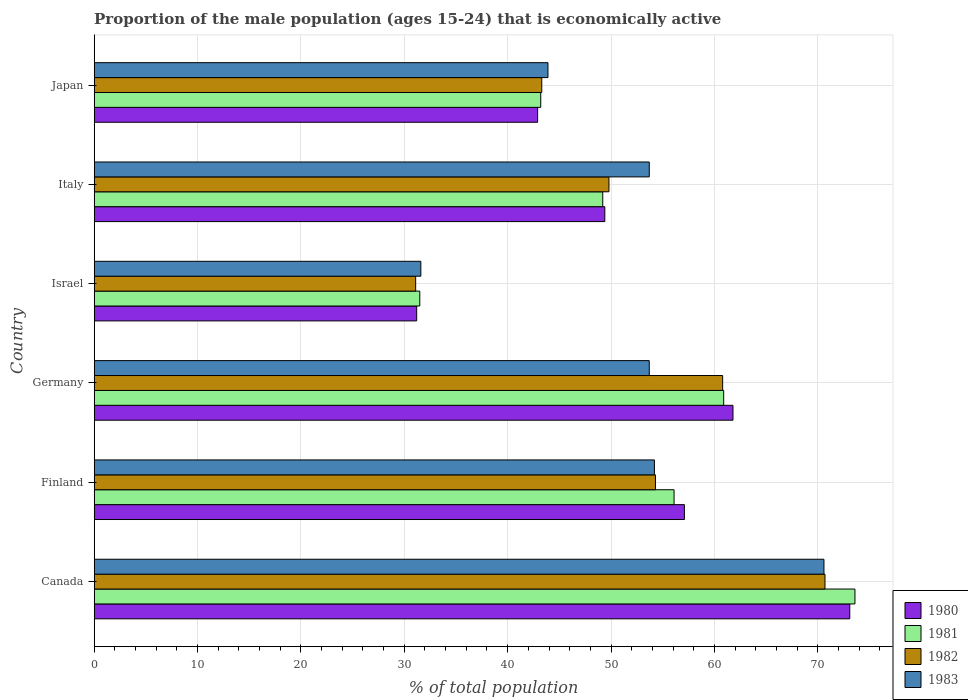How many different coloured bars are there?
Provide a succinct answer. 4. Are the number of bars per tick equal to the number of legend labels?
Provide a succinct answer. Yes. How many bars are there on the 6th tick from the top?
Your answer should be very brief. 4. In how many cases, is the number of bars for a given country not equal to the number of legend labels?
Provide a succinct answer. 0. What is the proportion of the male population that is economically active in 1980 in Finland?
Your answer should be compact. 57.1. Across all countries, what is the maximum proportion of the male population that is economically active in 1983?
Ensure brevity in your answer.  70.6. Across all countries, what is the minimum proportion of the male population that is economically active in 1983?
Ensure brevity in your answer.  31.6. What is the total proportion of the male population that is economically active in 1981 in the graph?
Your answer should be compact. 314.5. What is the difference between the proportion of the male population that is economically active in 1981 in Israel and the proportion of the male population that is economically active in 1983 in Germany?
Ensure brevity in your answer.  -22.2. What is the average proportion of the male population that is economically active in 1983 per country?
Give a very brief answer. 51.28. What is the difference between the proportion of the male population that is economically active in 1982 and proportion of the male population that is economically active in 1981 in Canada?
Your response must be concise. -2.9. In how many countries, is the proportion of the male population that is economically active in 1982 greater than 8 %?
Your answer should be very brief. 6. What is the ratio of the proportion of the male population that is economically active in 1980 in Italy to that in Japan?
Provide a succinct answer. 1.15. What is the difference between the highest and the second highest proportion of the male population that is economically active in 1980?
Offer a very short reply. 11.3. What is the difference between the highest and the lowest proportion of the male population that is economically active in 1983?
Give a very brief answer. 39. Is it the case that in every country, the sum of the proportion of the male population that is economically active in 1980 and proportion of the male population that is economically active in 1981 is greater than the sum of proportion of the male population that is economically active in 1983 and proportion of the male population that is economically active in 1982?
Your answer should be compact. No. What does the 4th bar from the top in Japan represents?
Keep it short and to the point. 1980. Is it the case that in every country, the sum of the proportion of the male population that is economically active in 1983 and proportion of the male population that is economically active in 1981 is greater than the proportion of the male population that is economically active in 1980?
Offer a very short reply. Yes. How many bars are there?
Ensure brevity in your answer.  24. What is the difference between two consecutive major ticks on the X-axis?
Offer a very short reply. 10. Are the values on the major ticks of X-axis written in scientific E-notation?
Your answer should be very brief. No. Does the graph contain grids?
Your response must be concise. Yes. How are the legend labels stacked?
Keep it short and to the point. Vertical. What is the title of the graph?
Your answer should be very brief. Proportion of the male population (ages 15-24) that is economically active. Does "1992" appear as one of the legend labels in the graph?
Keep it short and to the point. No. What is the label or title of the X-axis?
Offer a terse response. % of total population. What is the label or title of the Y-axis?
Provide a short and direct response. Country. What is the % of total population of 1980 in Canada?
Keep it short and to the point. 73.1. What is the % of total population of 1981 in Canada?
Keep it short and to the point. 73.6. What is the % of total population of 1982 in Canada?
Offer a very short reply. 70.7. What is the % of total population of 1983 in Canada?
Provide a short and direct response. 70.6. What is the % of total population of 1980 in Finland?
Provide a short and direct response. 57.1. What is the % of total population of 1981 in Finland?
Give a very brief answer. 56.1. What is the % of total population of 1982 in Finland?
Give a very brief answer. 54.3. What is the % of total population of 1983 in Finland?
Give a very brief answer. 54.2. What is the % of total population in 1980 in Germany?
Your answer should be compact. 61.8. What is the % of total population of 1981 in Germany?
Offer a terse response. 60.9. What is the % of total population in 1982 in Germany?
Your answer should be compact. 60.8. What is the % of total population of 1983 in Germany?
Keep it short and to the point. 53.7. What is the % of total population of 1980 in Israel?
Give a very brief answer. 31.2. What is the % of total population in 1981 in Israel?
Make the answer very short. 31.5. What is the % of total population in 1982 in Israel?
Provide a succinct answer. 31.1. What is the % of total population of 1983 in Israel?
Ensure brevity in your answer.  31.6. What is the % of total population of 1980 in Italy?
Your response must be concise. 49.4. What is the % of total population in 1981 in Italy?
Your answer should be compact. 49.2. What is the % of total population in 1982 in Italy?
Provide a short and direct response. 49.8. What is the % of total population in 1983 in Italy?
Your answer should be compact. 53.7. What is the % of total population in 1980 in Japan?
Provide a succinct answer. 42.9. What is the % of total population in 1981 in Japan?
Offer a terse response. 43.2. What is the % of total population of 1982 in Japan?
Provide a short and direct response. 43.3. What is the % of total population of 1983 in Japan?
Make the answer very short. 43.9. Across all countries, what is the maximum % of total population in 1980?
Your answer should be very brief. 73.1. Across all countries, what is the maximum % of total population in 1981?
Your answer should be very brief. 73.6. Across all countries, what is the maximum % of total population of 1982?
Provide a succinct answer. 70.7. Across all countries, what is the maximum % of total population in 1983?
Provide a succinct answer. 70.6. Across all countries, what is the minimum % of total population in 1980?
Give a very brief answer. 31.2. Across all countries, what is the minimum % of total population of 1981?
Keep it short and to the point. 31.5. Across all countries, what is the minimum % of total population of 1982?
Ensure brevity in your answer.  31.1. Across all countries, what is the minimum % of total population in 1983?
Keep it short and to the point. 31.6. What is the total % of total population of 1980 in the graph?
Make the answer very short. 315.5. What is the total % of total population of 1981 in the graph?
Give a very brief answer. 314.5. What is the total % of total population of 1982 in the graph?
Give a very brief answer. 310. What is the total % of total population in 1983 in the graph?
Provide a succinct answer. 307.7. What is the difference between the % of total population of 1980 in Canada and that in Finland?
Offer a terse response. 16. What is the difference between the % of total population in 1981 in Canada and that in Finland?
Offer a terse response. 17.5. What is the difference between the % of total population in 1982 in Canada and that in Finland?
Make the answer very short. 16.4. What is the difference between the % of total population of 1981 in Canada and that in Germany?
Make the answer very short. 12.7. What is the difference between the % of total population of 1983 in Canada and that in Germany?
Offer a terse response. 16.9. What is the difference between the % of total population in 1980 in Canada and that in Israel?
Your answer should be compact. 41.9. What is the difference between the % of total population in 1981 in Canada and that in Israel?
Your answer should be very brief. 42.1. What is the difference between the % of total population in 1982 in Canada and that in Israel?
Ensure brevity in your answer.  39.6. What is the difference between the % of total population in 1980 in Canada and that in Italy?
Offer a terse response. 23.7. What is the difference between the % of total population in 1981 in Canada and that in Italy?
Give a very brief answer. 24.4. What is the difference between the % of total population in 1982 in Canada and that in Italy?
Give a very brief answer. 20.9. What is the difference between the % of total population in 1983 in Canada and that in Italy?
Offer a very short reply. 16.9. What is the difference between the % of total population of 1980 in Canada and that in Japan?
Offer a very short reply. 30.2. What is the difference between the % of total population of 1981 in Canada and that in Japan?
Offer a very short reply. 30.4. What is the difference between the % of total population in 1982 in Canada and that in Japan?
Your answer should be very brief. 27.4. What is the difference between the % of total population in 1983 in Canada and that in Japan?
Provide a succinct answer. 26.7. What is the difference between the % of total population of 1981 in Finland and that in Germany?
Provide a succinct answer. -4.8. What is the difference between the % of total population of 1980 in Finland and that in Israel?
Offer a very short reply. 25.9. What is the difference between the % of total population in 1981 in Finland and that in Israel?
Provide a short and direct response. 24.6. What is the difference between the % of total population of 1982 in Finland and that in Israel?
Make the answer very short. 23.2. What is the difference between the % of total population in 1983 in Finland and that in Israel?
Make the answer very short. 22.6. What is the difference between the % of total population of 1981 in Finland and that in Italy?
Offer a very short reply. 6.9. What is the difference between the % of total population of 1982 in Finland and that in Italy?
Your answer should be very brief. 4.5. What is the difference between the % of total population of 1983 in Finland and that in Italy?
Keep it short and to the point. 0.5. What is the difference between the % of total population in 1981 in Finland and that in Japan?
Your response must be concise. 12.9. What is the difference between the % of total population in 1982 in Finland and that in Japan?
Your response must be concise. 11. What is the difference between the % of total population of 1983 in Finland and that in Japan?
Make the answer very short. 10.3. What is the difference between the % of total population of 1980 in Germany and that in Israel?
Give a very brief answer. 30.6. What is the difference between the % of total population in 1981 in Germany and that in Israel?
Your answer should be very brief. 29.4. What is the difference between the % of total population in 1982 in Germany and that in Israel?
Provide a succinct answer. 29.7. What is the difference between the % of total population in 1983 in Germany and that in Israel?
Make the answer very short. 22.1. What is the difference between the % of total population in 1980 in Germany and that in Italy?
Your answer should be very brief. 12.4. What is the difference between the % of total population of 1981 in Germany and that in Italy?
Your answer should be very brief. 11.7. What is the difference between the % of total population in 1982 in Germany and that in Italy?
Your answer should be compact. 11. What is the difference between the % of total population of 1983 in Germany and that in Italy?
Offer a very short reply. 0. What is the difference between the % of total population of 1980 in Germany and that in Japan?
Your answer should be compact. 18.9. What is the difference between the % of total population of 1982 in Germany and that in Japan?
Offer a terse response. 17.5. What is the difference between the % of total population in 1980 in Israel and that in Italy?
Your response must be concise. -18.2. What is the difference between the % of total population in 1981 in Israel and that in Italy?
Ensure brevity in your answer.  -17.7. What is the difference between the % of total population of 1982 in Israel and that in Italy?
Ensure brevity in your answer.  -18.7. What is the difference between the % of total population of 1983 in Israel and that in Italy?
Keep it short and to the point. -22.1. What is the difference between the % of total population in 1980 in Canada and the % of total population in 1981 in Finland?
Provide a short and direct response. 17. What is the difference between the % of total population in 1981 in Canada and the % of total population in 1982 in Finland?
Make the answer very short. 19.3. What is the difference between the % of total population of 1981 in Canada and the % of total population of 1983 in Finland?
Provide a succinct answer. 19.4. What is the difference between the % of total population in 1982 in Canada and the % of total population in 1983 in Finland?
Offer a very short reply. 16.5. What is the difference between the % of total population in 1980 in Canada and the % of total population in 1982 in Germany?
Keep it short and to the point. 12.3. What is the difference between the % of total population in 1981 in Canada and the % of total population in 1983 in Germany?
Offer a terse response. 19.9. What is the difference between the % of total population in 1980 in Canada and the % of total population in 1981 in Israel?
Give a very brief answer. 41.6. What is the difference between the % of total population of 1980 in Canada and the % of total population of 1983 in Israel?
Ensure brevity in your answer.  41.5. What is the difference between the % of total population of 1981 in Canada and the % of total population of 1982 in Israel?
Ensure brevity in your answer.  42.5. What is the difference between the % of total population of 1982 in Canada and the % of total population of 1983 in Israel?
Your response must be concise. 39.1. What is the difference between the % of total population in 1980 in Canada and the % of total population in 1981 in Italy?
Provide a short and direct response. 23.9. What is the difference between the % of total population in 1980 in Canada and the % of total population in 1982 in Italy?
Ensure brevity in your answer.  23.3. What is the difference between the % of total population of 1981 in Canada and the % of total population of 1982 in Italy?
Your answer should be compact. 23.8. What is the difference between the % of total population of 1980 in Canada and the % of total population of 1981 in Japan?
Your answer should be compact. 29.9. What is the difference between the % of total population in 1980 in Canada and the % of total population in 1982 in Japan?
Your response must be concise. 29.8. What is the difference between the % of total population of 1980 in Canada and the % of total population of 1983 in Japan?
Offer a terse response. 29.2. What is the difference between the % of total population in 1981 in Canada and the % of total population in 1982 in Japan?
Your answer should be compact. 30.3. What is the difference between the % of total population of 1981 in Canada and the % of total population of 1983 in Japan?
Provide a short and direct response. 29.7. What is the difference between the % of total population of 1982 in Canada and the % of total population of 1983 in Japan?
Make the answer very short. 26.8. What is the difference between the % of total population of 1980 in Finland and the % of total population of 1981 in Germany?
Ensure brevity in your answer.  -3.8. What is the difference between the % of total population in 1980 in Finland and the % of total population in 1983 in Germany?
Keep it short and to the point. 3.4. What is the difference between the % of total population in 1980 in Finland and the % of total population in 1981 in Israel?
Keep it short and to the point. 25.6. What is the difference between the % of total population of 1980 in Finland and the % of total population of 1983 in Israel?
Your answer should be very brief. 25.5. What is the difference between the % of total population of 1982 in Finland and the % of total population of 1983 in Israel?
Provide a succinct answer. 22.7. What is the difference between the % of total population in 1980 in Finland and the % of total population in 1981 in Italy?
Provide a short and direct response. 7.9. What is the difference between the % of total population in 1980 in Finland and the % of total population in 1982 in Italy?
Offer a very short reply. 7.3. What is the difference between the % of total population in 1981 in Finland and the % of total population in 1982 in Italy?
Ensure brevity in your answer.  6.3. What is the difference between the % of total population in 1980 in Finland and the % of total population in 1981 in Japan?
Make the answer very short. 13.9. What is the difference between the % of total population of 1980 in Finland and the % of total population of 1982 in Japan?
Your answer should be compact. 13.8. What is the difference between the % of total population in 1981 in Finland and the % of total population in 1982 in Japan?
Offer a very short reply. 12.8. What is the difference between the % of total population in 1981 in Finland and the % of total population in 1983 in Japan?
Your answer should be compact. 12.2. What is the difference between the % of total population in 1982 in Finland and the % of total population in 1983 in Japan?
Offer a terse response. 10.4. What is the difference between the % of total population of 1980 in Germany and the % of total population of 1981 in Israel?
Your answer should be compact. 30.3. What is the difference between the % of total population of 1980 in Germany and the % of total population of 1982 in Israel?
Offer a terse response. 30.7. What is the difference between the % of total population of 1980 in Germany and the % of total population of 1983 in Israel?
Your answer should be very brief. 30.2. What is the difference between the % of total population of 1981 in Germany and the % of total population of 1982 in Israel?
Provide a succinct answer. 29.8. What is the difference between the % of total population of 1981 in Germany and the % of total population of 1983 in Israel?
Provide a succinct answer. 29.3. What is the difference between the % of total population in 1982 in Germany and the % of total population in 1983 in Israel?
Provide a short and direct response. 29.2. What is the difference between the % of total population of 1980 in Germany and the % of total population of 1982 in Italy?
Your response must be concise. 12. What is the difference between the % of total population in 1980 in Germany and the % of total population in 1983 in Italy?
Your response must be concise. 8.1. What is the difference between the % of total population in 1981 in Germany and the % of total population in 1982 in Italy?
Keep it short and to the point. 11.1. What is the difference between the % of total population of 1981 in Germany and the % of total population of 1983 in Italy?
Keep it short and to the point. 7.2. What is the difference between the % of total population in 1982 in Germany and the % of total population in 1983 in Italy?
Ensure brevity in your answer.  7.1. What is the difference between the % of total population of 1980 in Germany and the % of total population of 1983 in Japan?
Keep it short and to the point. 17.9. What is the difference between the % of total population of 1981 in Germany and the % of total population of 1982 in Japan?
Provide a succinct answer. 17.6. What is the difference between the % of total population in 1981 in Germany and the % of total population in 1983 in Japan?
Your answer should be very brief. 17. What is the difference between the % of total population of 1982 in Germany and the % of total population of 1983 in Japan?
Offer a very short reply. 16.9. What is the difference between the % of total population of 1980 in Israel and the % of total population of 1981 in Italy?
Provide a short and direct response. -18. What is the difference between the % of total population of 1980 in Israel and the % of total population of 1982 in Italy?
Offer a terse response. -18.6. What is the difference between the % of total population in 1980 in Israel and the % of total population in 1983 in Italy?
Your answer should be very brief. -22.5. What is the difference between the % of total population in 1981 in Israel and the % of total population in 1982 in Italy?
Offer a terse response. -18.3. What is the difference between the % of total population in 1981 in Israel and the % of total population in 1983 in Italy?
Keep it short and to the point. -22.2. What is the difference between the % of total population of 1982 in Israel and the % of total population of 1983 in Italy?
Your answer should be very brief. -22.6. What is the difference between the % of total population in 1980 in Israel and the % of total population in 1982 in Japan?
Your response must be concise. -12.1. What is the difference between the % of total population of 1980 in Israel and the % of total population of 1983 in Japan?
Give a very brief answer. -12.7. What is the difference between the % of total population in 1981 in Israel and the % of total population in 1983 in Japan?
Provide a short and direct response. -12.4. What is the difference between the % of total population in 1980 in Italy and the % of total population in 1981 in Japan?
Provide a succinct answer. 6.2. What is the difference between the % of total population in 1980 in Italy and the % of total population in 1982 in Japan?
Your response must be concise. 6.1. What is the difference between the % of total population of 1980 in Italy and the % of total population of 1983 in Japan?
Your answer should be compact. 5.5. What is the difference between the % of total population of 1981 in Italy and the % of total population of 1982 in Japan?
Provide a short and direct response. 5.9. What is the difference between the % of total population in 1982 in Italy and the % of total population in 1983 in Japan?
Your answer should be compact. 5.9. What is the average % of total population in 1980 per country?
Provide a short and direct response. 52.58. What is the average % of total population of 1981 per country?
Give a very brief answer. 52.42. What is the average % of total population in 1982 per country?
Offer a very short reply. 51.67. What is the average % of total population in 1983 per country?
Keep it short and to the point. 51.28. What is the difference between the % of total population of 1980 and % of total population of 1982 in Canada?
Offer a very short reply. 2.4. What is the difference between the % of total population in 1980 and % of total population in 1983 in Canada?
Ensure brevity in your answer.  2.5. What is the difference between the % of total population of 1981 and % of total population of 1983 in Canada?
Provide a short and direct response. 3. What is the difference between the % of total population of 1980 and % of total population of 1982 in Finland?
Keep it short and to the point. 2.8. What is the difference between the % of total population of 1981 and % of total population of 1983 in Finland?
Make the answer very short. 1.9. What is the difference between the % of total population of 1982 and % of total population of 1983 in Finland?
Keep it short and to the point. 0.1. What is the difference between the % of total population in 1980 and % of total population in 1981 in Germany?
Provide a short and direct response. 0.9. What is the difference between the % of total population of 1981 and % of total population of 1982 in Germany?
Provide a short and direct response. 0.1. What is the difference between the % of total population of 1980 and % of total population of 1981 in Israel?
Your response must be concise. -0.3. What is the difference between the % of total population of 1981 and % of total population of 1983 in Israel?
Keep it short and to the point. -0.1. What is the difference between the % of total population of 1980 and % of total population of 1981 in Italy?
Offer a terse response. 0.2. What is the difference between the % of total population in 1980 and % of total population in 1983 in Italy?
Offer a terse response. -4.3. What is the difference between the % of total population in 1981 and % of total population in 1982 in Italy?
Offer a very short reply. -0.6. What is the difference between the % of total population of 1982 and % of total population of 1983 in Italy?
Provide a short and direct response. -3.9. What is the difference between the % of total population of 1980 and % of total population of 1983 in Japan?
Keep it short and to the point. -1. What is the difference between the % of total population of 1982 and % of total population of 1983 in Japan?
Your answer should be compact. -0.6. What is the ratio of the % of total population in 1980 in Canada to that in Finland?
Give a very brief answer. 1.28. What is the ratio of the % of total population of 1981 in Canada to that in Finland?
Offer a terse response. 1.31. What is the ratio of the % of total population in 1982 in Canada to that in Finland?
Make the answer very short. 1.3. What is the ratio of the % of total population of 1983 in Canada to that in Finland?
Offer a terse response. 1.3. What is the ratio of the % of total population of 1980 in Canada to that in Germany?
Provide a succinct answer. 1.18. What is the ratio of the % of total population in 1981 in Canada to that in Germany?
Your answer should be very brief. 1.21. What is the ratio of the % of total population in 1982 in Canada to that in Germany?
Your answer should be compact. 1.16. What is the ratio of the % of total population of 1983 in Canada to that in Germany?
Offer a very short reply. 1.31. What is the ratio of the % of total population in 1980 in Canada to that in Israel?
Provide a short and direct response. 2.34. What is the ratio of the % of total population of 1981 in Canada to that in Israel?
Your answer should be compact. 2.34. What is the ratio of the % of total population of 1982 in Canada to that in Israel?
Your response must be concise. 2.27. What is the ratio of the % of total population in 1983 in Canada to that in Israel?
Keep it short and to the point. 2.23. What is the ratio of the % of total population of 1980 in Canada to that in Italy?
Your answer should be compact. 1.48. What is the ratio of the % of total population in 1981 in Canada to that in Italy?
Ensure brevity in your answer.  1.5. What is the ratio of the % of total population in 1982 in Canada to that in Italy?
Provide a succinct answer. 1.42. What is the ratio of the % of total population in 1983 in Canada to that in Italy?
Your answer should be very brief. 1.31. What is the ratio of the % of total population in 1980 in Canada to that in Japan?
Ensure brevity in your answer.  1.7. What is the ratio of the % of total population in 1981 in Canada to that in Japan?
Give a very brief answer. 1.7. What is the ratio of the % of total population in 1982 in Canada to that in Japan?
Give a very brief answer. 1.63. What is the ratio of the % of total population of 1983 in Canada to that in Japan?
Your response must be concise. 1.61. What is the ratio of the % of total population of 1980 in Finland to that in Germany?
Offer a very short reply. 0.92. What is the ratio of the % of total population of 1981 in Finland to that in Germany?
Provide a short and direct response. 0.92. What is the ratio of the % of total population in 1982 in Finland to that in Germany?
Your answer should be compact. 0.89. What is the ratio of the % of total population of 1983 in Finland to that in Germany?
Your answer should be compact. 1.01. What is the ratio of the % of total population of 1980 in Finland to that in Israel?
Provide a succinct answer. 1.83. What is the ratio of the % of total population of 1981 in Finland to that in Israel?
Provide a short and direct response. 1.78. What is the ratio of the % of total population of 1982 in Finland to that in Israel?
Your answer should be compact. 1.75. What is the ratio of the % of total population in 1983 in Finland to that in Israel?
Make the answer very short. 1.72. What is the ratio of the % of total population in 1980 in Finland to that in Italy?
Offer a very short reply. 1.16. What is the ratio of the % of total population of 1981 in Finland to that in Italy?
Ensure brevity in your answer.  1.14. What is the ratio of the % of total population of 1982 in Finland to that in Italy?
Keep it short and to the point. 1.09. What is the ratio of the % of total population in 1983 in Finland to that in Italy?
Your response must be concise. 1.01. What is the ratio of the % of total population of 1980 in Finland to that in Japan?
Provide a short and direct response. 1.33. What is the ratio of the % of total population in 1981 in Finland to that in Japan?
Give a very brief answer. 1.3. What is the ratio of the % of total population of 1982 in Finland to that in Japan?
Provide a short and direct response. 1.25. What is the ratio of the % of total population in 1983 in Finland to that in Japan?
Provide a short and direct response. 1.23. What is the ratio of the % of total population in 1980 in Germany to that in Israel?
Give a very brief answer. 1.98. What is the ratio of the % of total population of 1981 in Germany to that in Israel?
Offer a terse response. 1.93. What is the ratio of the % of total population in 1982 in Germany to that in Israel?
Give a very brief answer. 1.96. What is the ratio of the % of total population in 1983 in Germany to that in Israel?
Make the answer very short. 1.7. What is the ratio of the % of total population in 1980 in Germany to that in Italy?
Provide a short and direct response. 1.25. What is the ratio of the % of total population of 1981 in Germany to that in Italy?
Keep it short and to the point. 1.24. What is the ratio of the % of total population of 1982 in Germany to that in Italy?
Your response must be concise. 1.22. What is the ratio of the % of total population of 1983 in Germany to that in Italy?
Your answer should be compact. 1. What is the ratio of the % of total population in 1980 in Germany to that in Japan?
Provide a succinct answer. 1.44. What is the ratio of the % of total population in 1981 in Germany to that in Japan?
Ensure brevity in your answer.  1.41. What is the ratio of the % of total population in 1982 in Germany to that in Japan?
Your response must be concise. 1.4. What is the ratio of the % of total population of 1983 in Germany to that in Japan?
Offer a terse response. 1.22. What is the ratio of the % of total population in 1980 in Israel to that in Italy?
Provide a short and direct response. 0.63. What is the ratio of the % of total population of 1981 in Israel to that in Italy?
Offer a terse response. 0.64. What is the ratio of the % of total population in 1982 in Israel to that in Italy?
Provide a succinct answer. 0.62. What is the ratio of the % of total population in 1983 in Israel to that in Italy?
Your answer should be very brief. 0.59. What is the ratio of the % of total population of 1980 in Israel to that in Japan?
Your answer should be very brief. 0.73. What is the ratio of the % of total population in 1981 in Israel to that in Japan?
Your response must be concise. 0.73. What is the ratio of the % of total population of 1982 in Israel to that in Japan?
Keep it short and to the point. 0.72. What is the ratio of the % of total population in 1983 in Israel to that in Japan?
Keep it short and to the point. 0.72. What is the ratio of the % of total population in 1980 in Italy to that in Japan?
Offer a very short reply. 1.15. What is the ratio of the % of total population in 1981 in Italy to that in Japan?
Keep it short and to the point. 1.14. What is the ratio of the % of total population in 1982 in Italy to that in Japan?
Provide a succinct answer. 1.15. What is the ratio of the % of total population in 1983 in Italy to that in Japan?
Your answer should be very brief. 1.22. What is the difference between the highest and the second highest % of total population in 1980?
Offer a very short reply. 11.3. What is the difference between the highest and the second highest % of total population in 1981?
Offer a terse response. 12.7. What is the difference between the highest and the second highest % of total population of 1982?
Your answer should be very brief. 9.9. What is the difference between the highest and the lowest % of total population of 1980?
Keep it short and to the point. 41.9. What is the difference between the highest and the lowest % of total population in 1981?
Make the answer very short. 42.1. What is the difference between the highest and the lowest % of total population in 1982?
Ensure brevity in your answer.  39.6. 